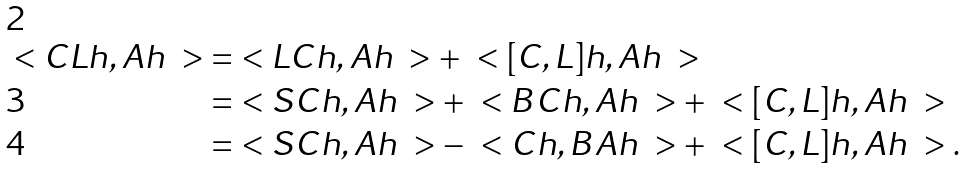<formula> <loc_0><loc_0><loc_500><loc_500>\ < C L h , A h \ > & = \ < L C h , A h \ > + \ < [ C , L ] h , A h \ > \\ & = \ < S C h , A h \ > + \ < B C h , A h \ > + \ < [ C , L ] h , A h \ > \\ & = \ < S C h , A h \ > - \ < C h , B A h \ > + \ < [ C , L ] h , A h \ > .</formula> 